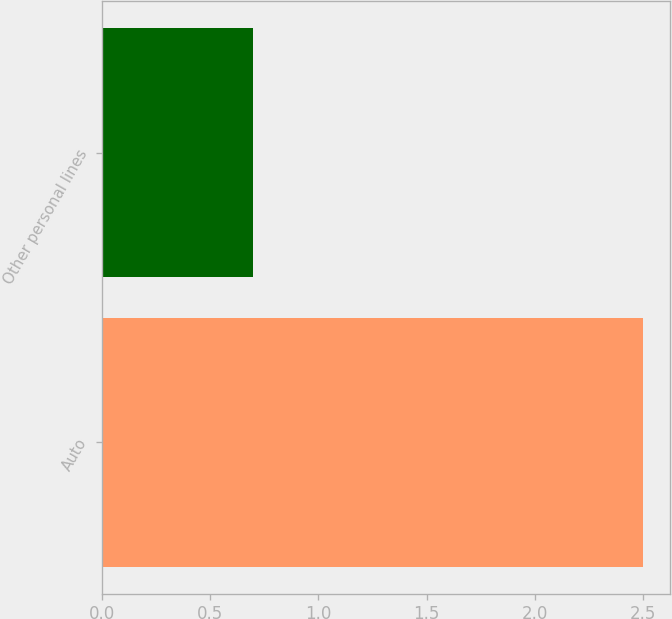Convert chart. <chart><loc_0><loc_0><loc_500><loc_500><bar_chart><fcel>Auto<fcel>Other personal lines<nl><fcel>2.5<fcel>0.7<nl></chart> 